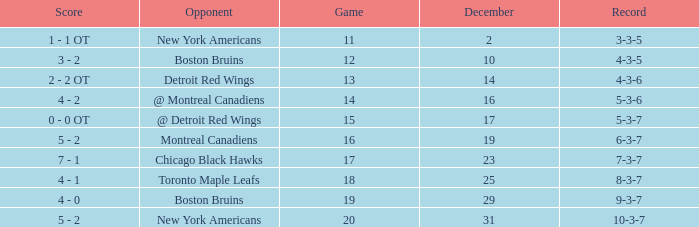Which Game is the highest one that has a Record of 4-3-6? 13.0. 